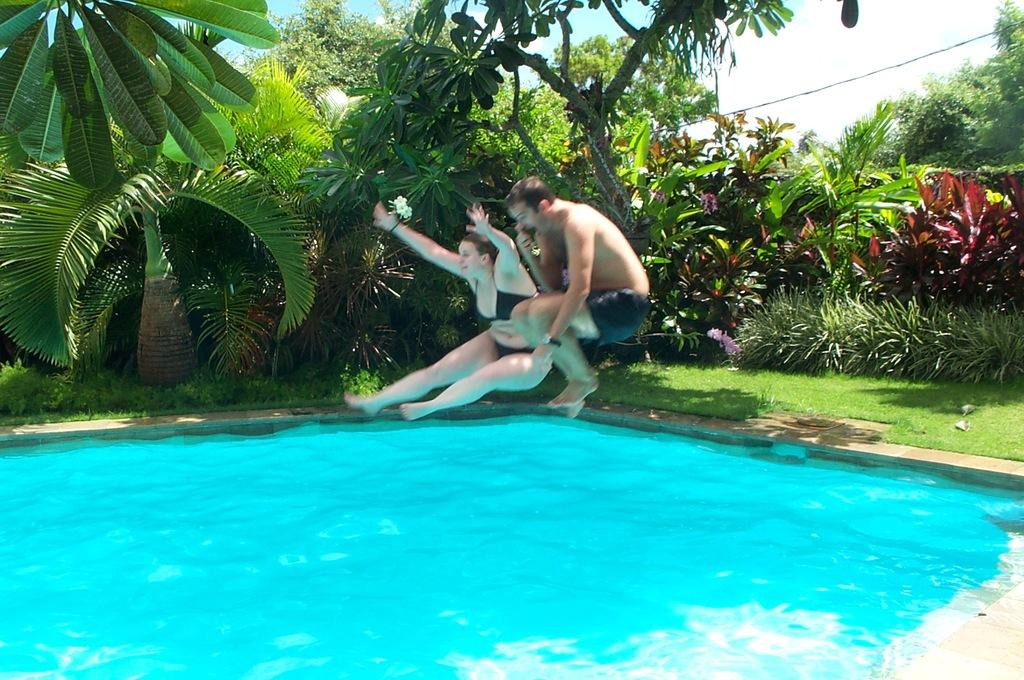Who are the people in the image? There is a man and a woman in the image. What are the man and the woman doing in the image? Both the man and the woman are jumping in a swimming pool. What can be seen in the background of the image? There are plants and trees visible in the background of the image. What type of bean is the man holding in the image? There is no bean present in the image; the man and the woman are jumping in a swimming pool. Does the woman have a tail in the image? No, the woman does not have a tail in the image; she is a human. 